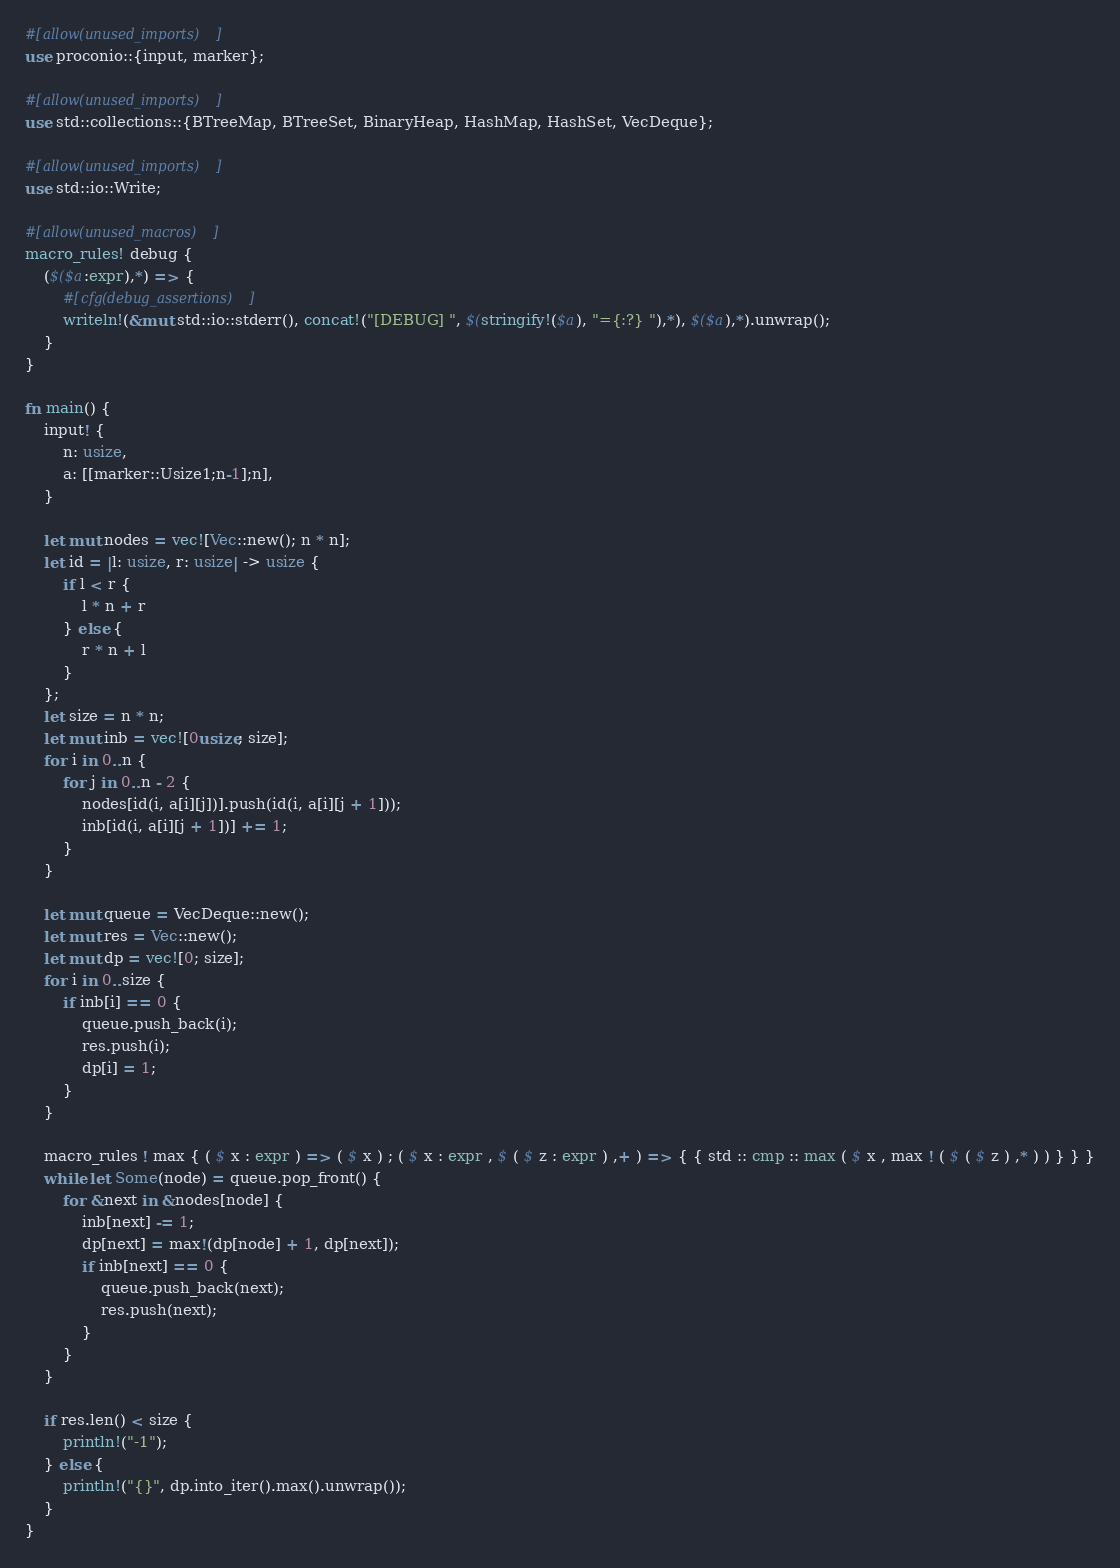Convert code to text. <code><loc_0><loc_0><loc_500><loc_500><_Rust_>#[allow(unused_imports)]
use proconio::{input, marker};

#[allow(unused_imports)]
use std::collections::{BTreeMap, BTreeSet, BinaryHeap, HashMap, HashSet, VecDeque};

#[allow(unused_imports)]
use std::io::Write;

#[allow(unused_macros)]
macro_rules! debug {
    ($($a:expr),*) => {
        #[cfg(debug_assertions)]
        writeln!(&mut std::io::stderr(), concat!("[DEBUG] ", $(stringify!($a), "={:?} "),*), $($a),*).unwrap();
    }
}

fn main() {
    input! {
        n: usize,
        a: [[marker::Usize1;n-1];n],
    }

    let mut nodes = vec![Vec::new(); n * n];
    let id = |l: usize, r: usize| -> usize {
        if l < r {
            l * n + r
        } else {
            r * n + l
        }
    };
    let size = n * n;
    let mut inb = vec![0usize; size];
    for i in 0..n {
        for j in 0..n - 2 {
            nodes[id(i, a[i][j])].push(id(i, a[i][j + 1]));
            inb[id(i, a[i][j + 1])] += 1;
        }
    }

    let mut queue = VecDeque::new();
    let mut res = Vec::new();
    let mut dp = vec![0; size];
    for i in 0..size {
        if inb[i] == 0 {
            queue.push_back(i);
            res.push(i);
            dp[i] = 1;
        }
    }

    macro_rules ! max { ( $ x : expr ) => ( $ x ) ; ( $ x : expr , $ ( $ z : expr ) ,+ ) => { { std :: cmp :: max ( $ x , max ! ( $ ( $ z ) ,* ) ) } } }
    while let Some(node) = queue.pop_front() {
        for &next in &nodes[node] {
            inb[next] -= 1;
            dp[next] = max!(dp[node] + 1, dp[next]);
            if inb[next] == 0 {
                queue.push_back(next);
                res.push(next);
            }
        }
    }

    if res.len() < size {
        println!("-1");
    } else {
        println!("{}", dp.into_iter().max().unwrap());
    }
}
</code> 